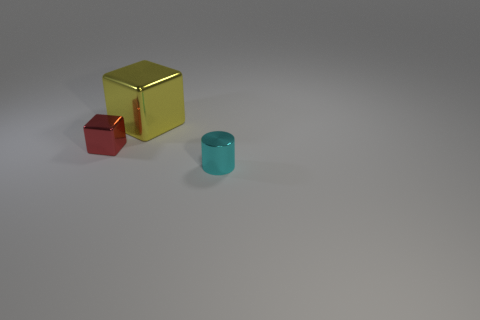Add 1 tiny brown cylinders. How many objects exist? 4 Subtract all cubes. How many objects are left? 1 Add 3 large red matte cubes. How many large red matte cubes exist? 3 Subtract 0 gray cylinders. How many objects are left? 3 Subtract all big cyan metallic cubes. Subtract all tiny metal blocks. How many objects are left? 2 Add 1 large yellow objects. How many large yellow objects are left? 2 